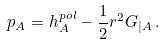Convert formula to latex. <formula><loc_0><loc_0><loc_500><loc_500>p _ { A } = h ^ { p o l } _ { A } - \frac { 1 } { 2 } r ^ { 2 } G _ { | A } \, .</formula> 